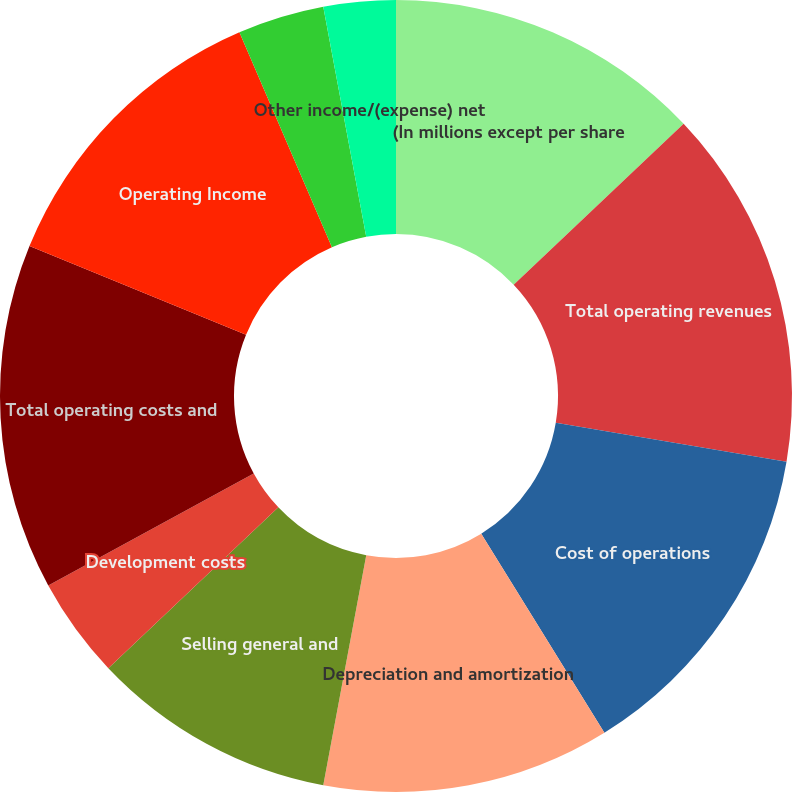Convert chart to OTSL. <chart><loc_0><loc_0><loc_500><loc_500><pie_chart><fcel>(In millions except per share<fcel>Total operating revenues<fcel>Cost of operations<fcel>Depreciation and amortization<fcel>Selling general and<fcel>Development costs<fcel>Total operating costs and<fcel>Operating Income<fcel>Equity in earnings of<fcel>Other income/(expense) net<nl><fcel>12.94%<fcel>14.71%<fcel>13.53%<fcel>11.76%<fcel>10.0%<fcel>4.12%<fcel>14.12%<fcel>12.35%<fcel>3.53%<fcel>2.94%<nl></chart> 